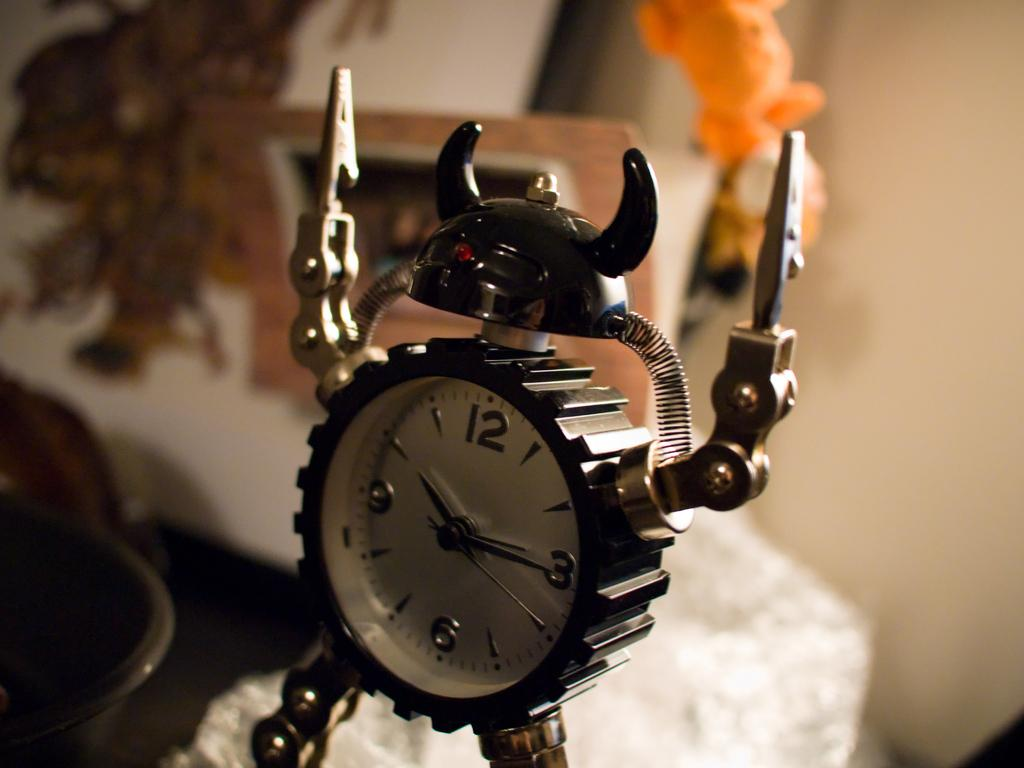<image>
Give a short and clear explanation of the subsequent image. A clock that is shaped like a robot shows the time is 10:15. 